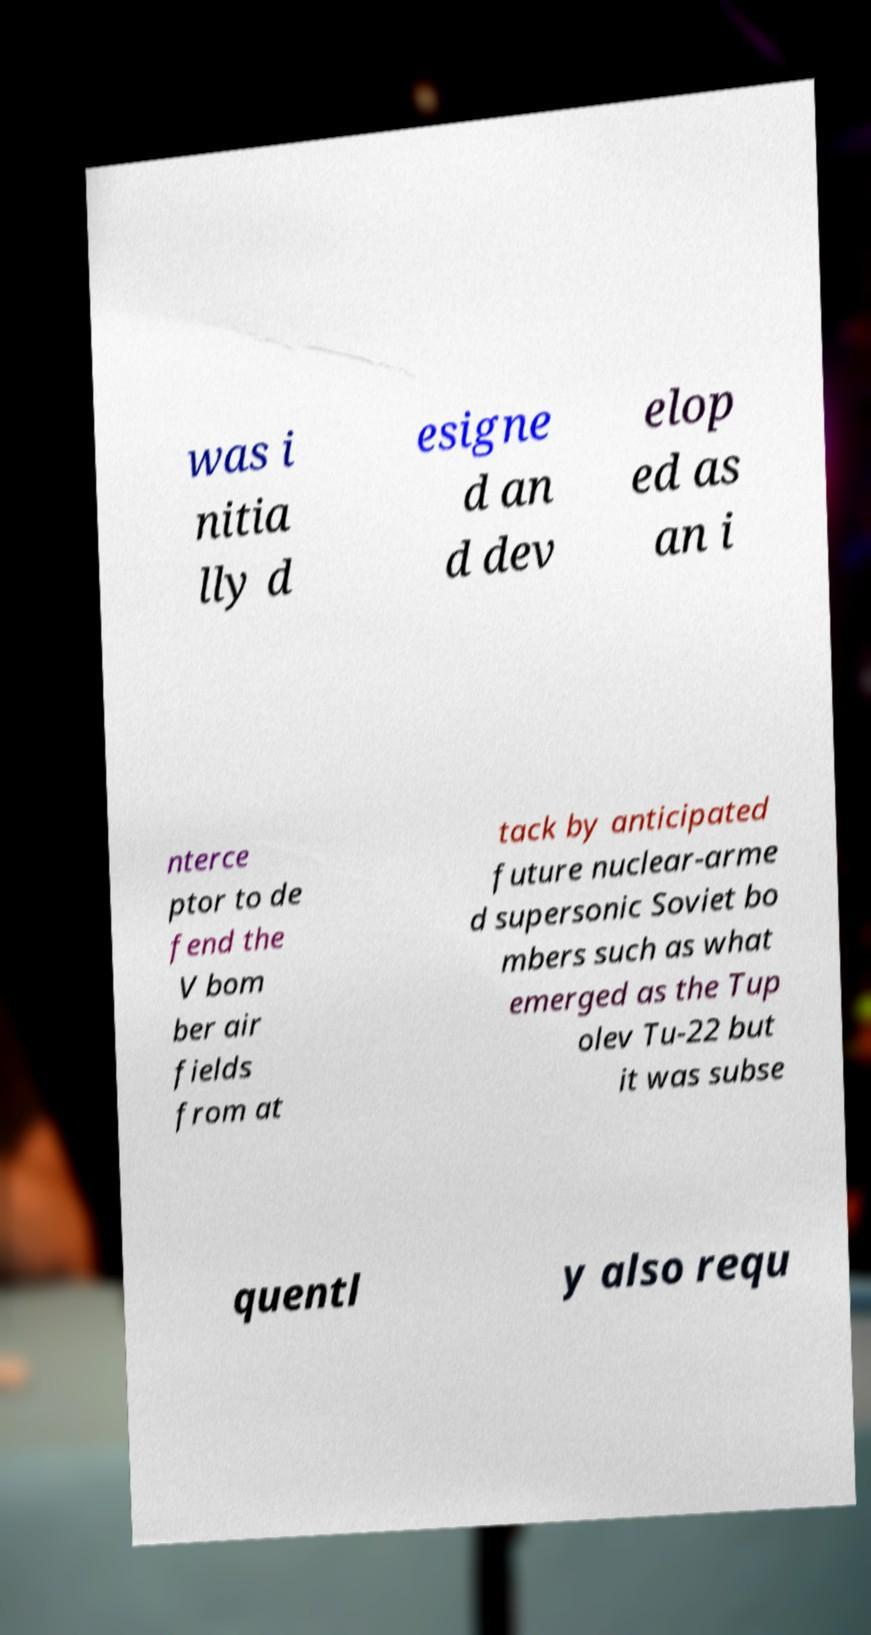I need the written content from this picture converted into text. Can you do that? was i nitia lly d esigne d an d dev elop ed as an i nterce ptor to de fend the V bom ber air fields from at tack by anticipated future nuclear-arme d supersonic Soviet bo mbers such as what emerged as the Tup olev Tu-22 but it was subse quentl y also requ 